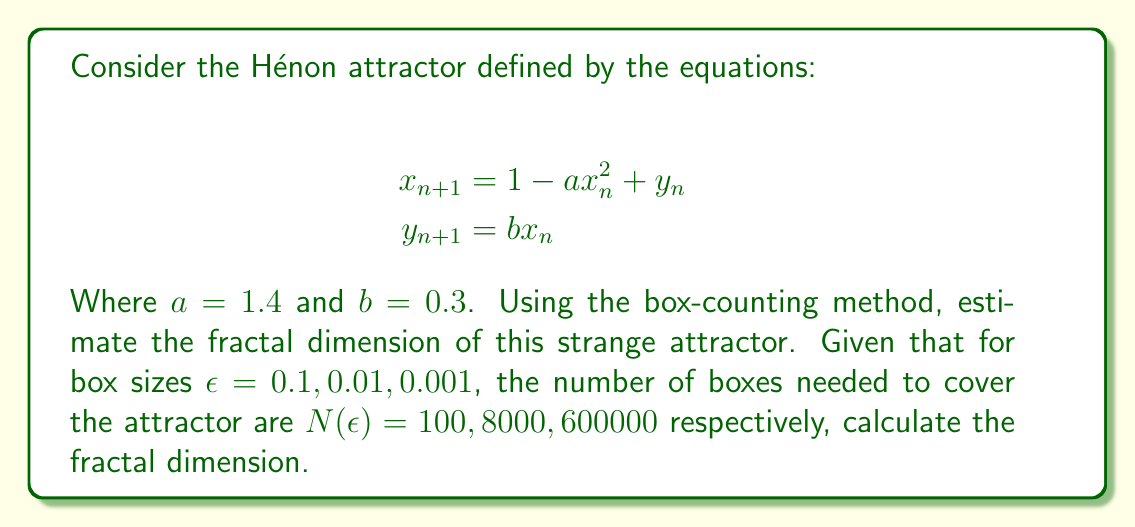Provide a solution to this math problem. To estimate the fractal dimension using the box-counting method, we follow these steps:

1) The box-counting dimension is defined as:

   $$D = \lim_{\epsilon \to 0} \frac{\log N(\epsilon)}{\log(1/\epsilon)}$$

2) For practical purposes, we can estimate this by calculating the slope of the line in a log-log plot of $N(\epsilon)$ vs. $1/\epsilon$.

3) Let's organize our data:
   
   $\epsilon_1 = 0.1$,    $N(\epsilon_1) = 100$
   $\epsilon_2 = 0.01$,   $N(\epsilon_2) = 8000$
   $\epsilon_3 = 0.001$,  $N(\epsilon_3) = 600000$

4) We'll use the first and last points to estimate the dimension:

   $$D \approx \frac{\log(N(\epsilon_3)) - \log(N(\epsilon_1))}{\log(1/\epsilon_3) - \log(1/\epsilon_1)}$$

5) Substituting the values:

   $$D \approx \frac{\log(600000) - \log(100)}{\log(1000) - \log(10)}$$

6) Simplifying:

   $$D \approx \frac{\log(6000)}{\log(100)} = \frac{\log(6000)}{\log(100)} \approx 1.2618$$

Therefore, the estimated fractal dimension of the Hénon attractor is approximately 1.2618.
Answer: $D \approx 1.2618$ 